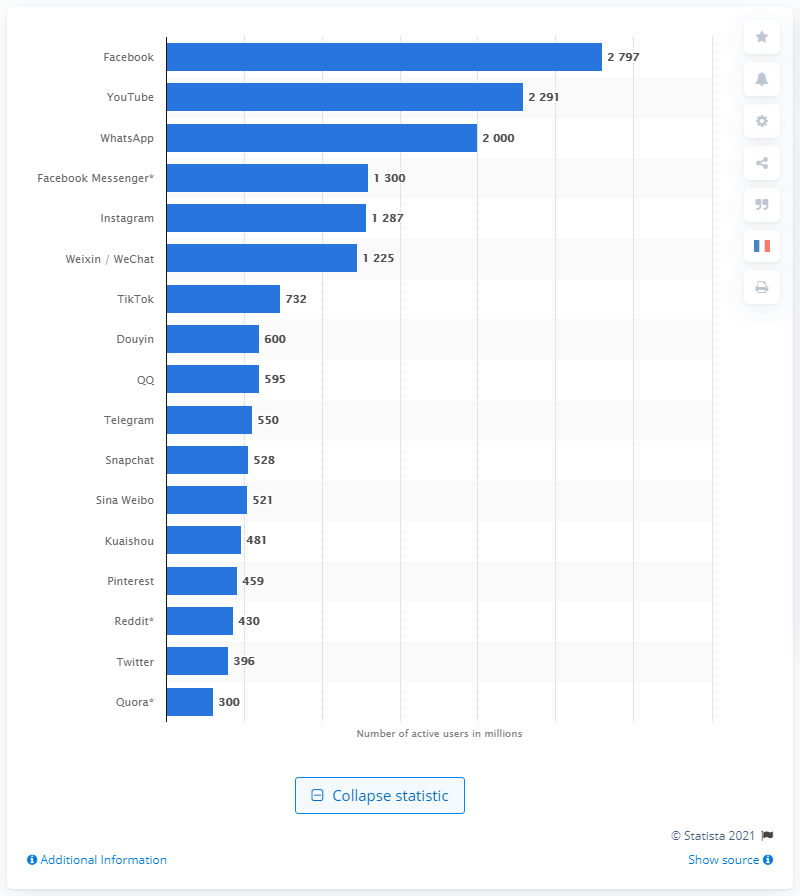Indicate a few pertinent items in this graphic. Facebook is the most widely used social network worldwide. 